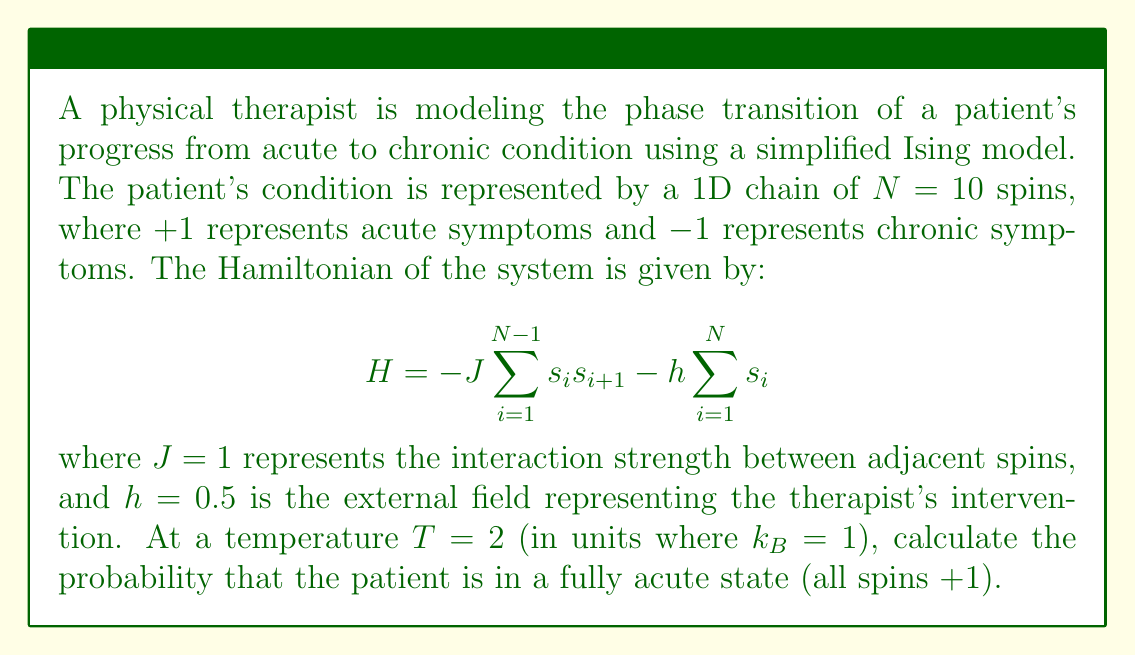What is the answer to this math problem? To solve this problem, we'll follow these steps:

1) First, we need to calculate the energy of the fully acute state (all spins $+1$):

   $$E_{acute} = -J\sum_{i=1}^{N-1} (+1)(+1) - h\sum_{i=1}^N (+1)$$
   $$E_{acute} = -J(N-1) - hN = -1(9) - 0.5(10) = -14$$

2) Now, we need to calculate the partition function $Z$. For a system with $N=10$ spins, there are $2^{10}=1024$ possible states. Calculating $Z$ exactly would be tedious, so we'll use the approximation that the partition function is dominated by the lowest energy states:

   $$Z \approx e^{-E_{acute}/T} + e^{-E_{chronic}/T}$$

   where $E_{chronic} = E_{acute}$ (due to symmetry of the Hamiltonian).

3) Let's calculate $Z$:

   $$Z \approx 2e^{-E_{acute}/T} = 2e^{14/2} = 2e^7 \approx 2221.41$$

4) The probability of the fully acute state is given by:

   $$P_{acute} = \frac{e^{-E_{acute}/T}}{Z} = \frac{e^{14/2}}{2e^7} = \frac{1}{2} = 0.5$$

Therefore, the probability that the patient is in a fully acute state is approximately 0.5 or 50%.
Answer: 0.5 